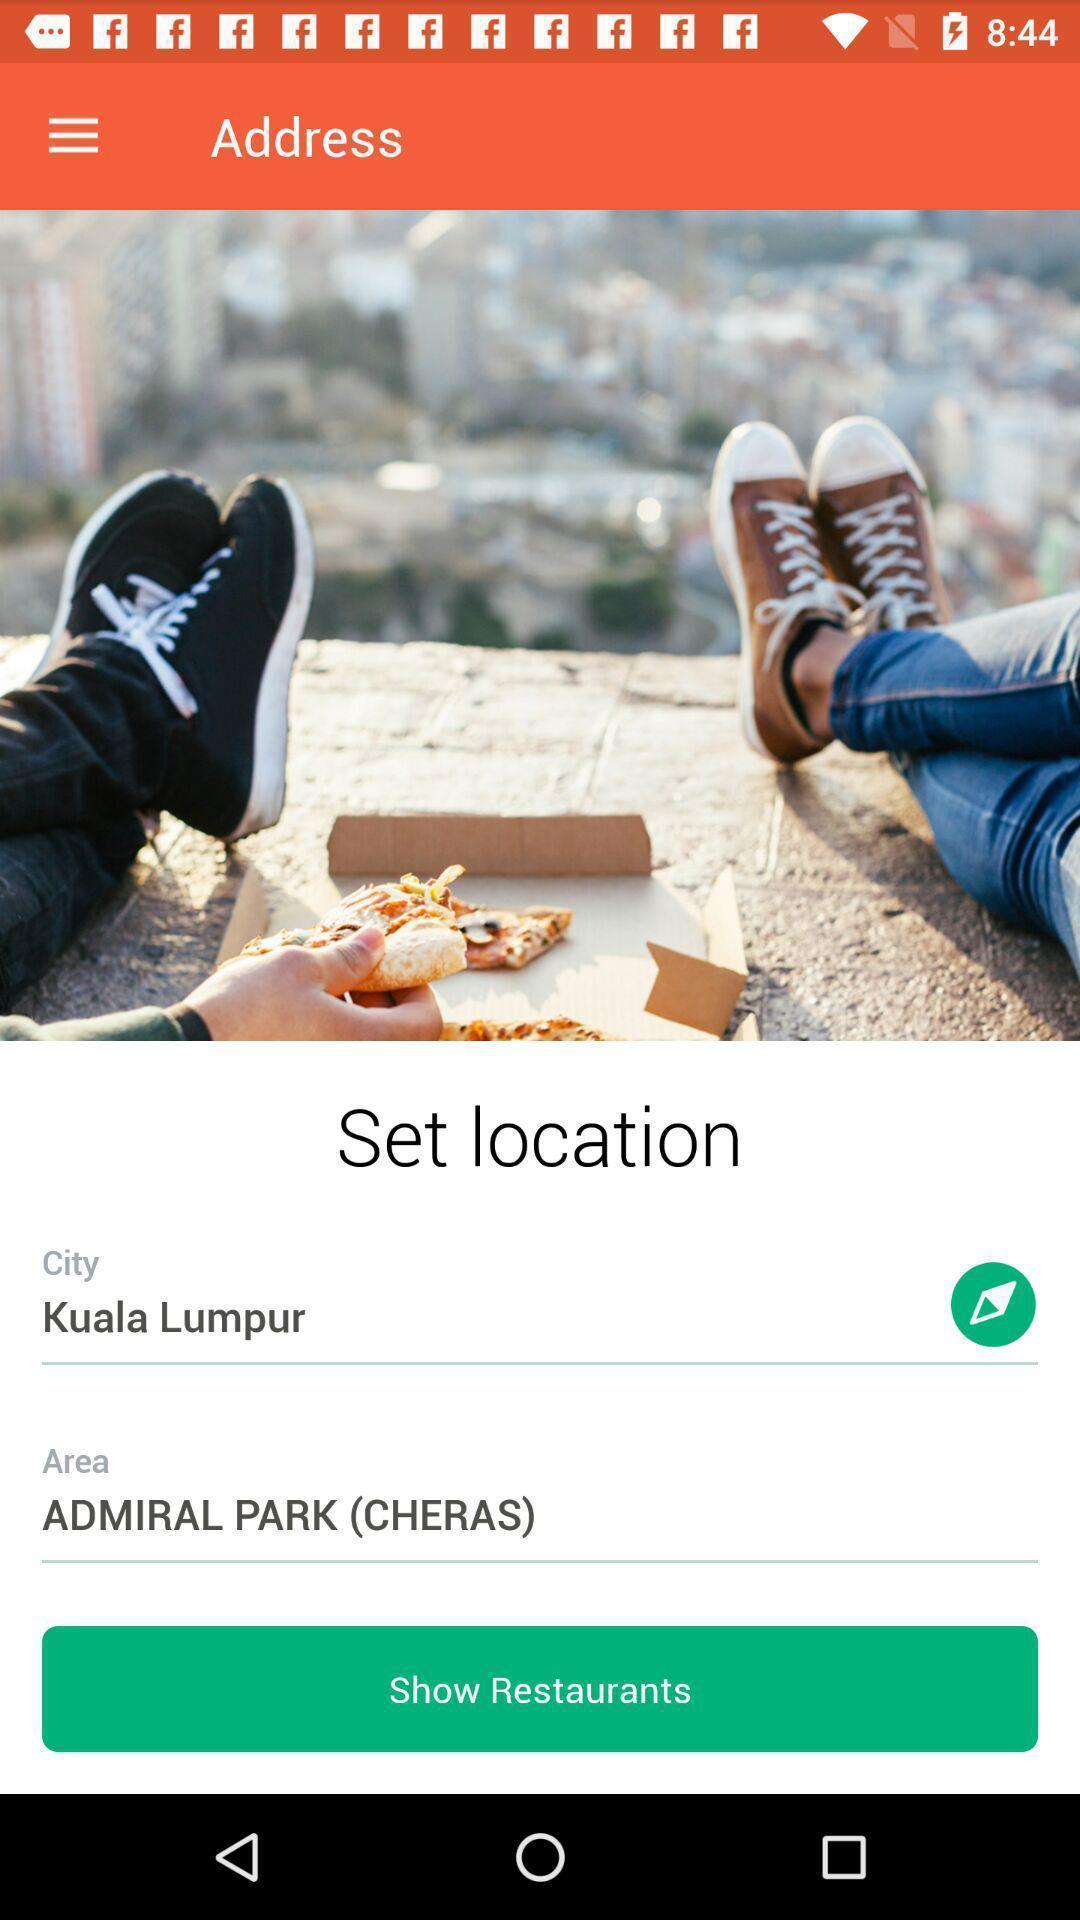Describe the key features of this screenshot. Page showing the input fields for location. 